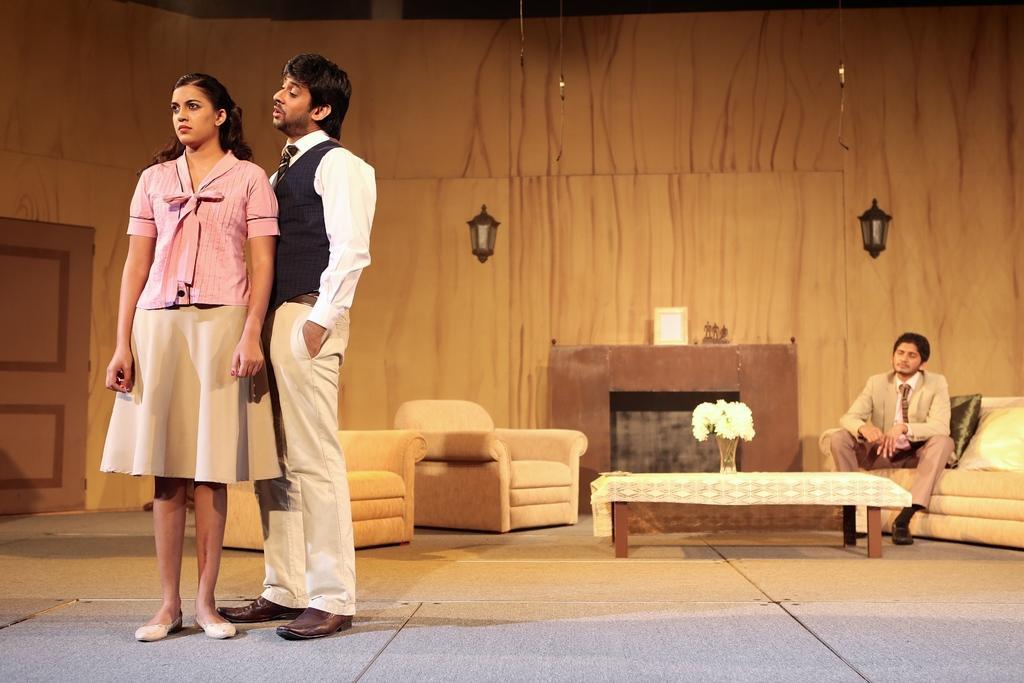How would you summarize this image in a sentence or two? in this image there are two persons standing on the floor one is woman and one is man on right side there is man sitting on the sofa and in the middle some things are there couches,table,flower vase and the two lamps and on the left side there is door and the background is white. 